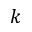<formula> <loc_0><loc_0><loc_500><loc_500>k</formula> 